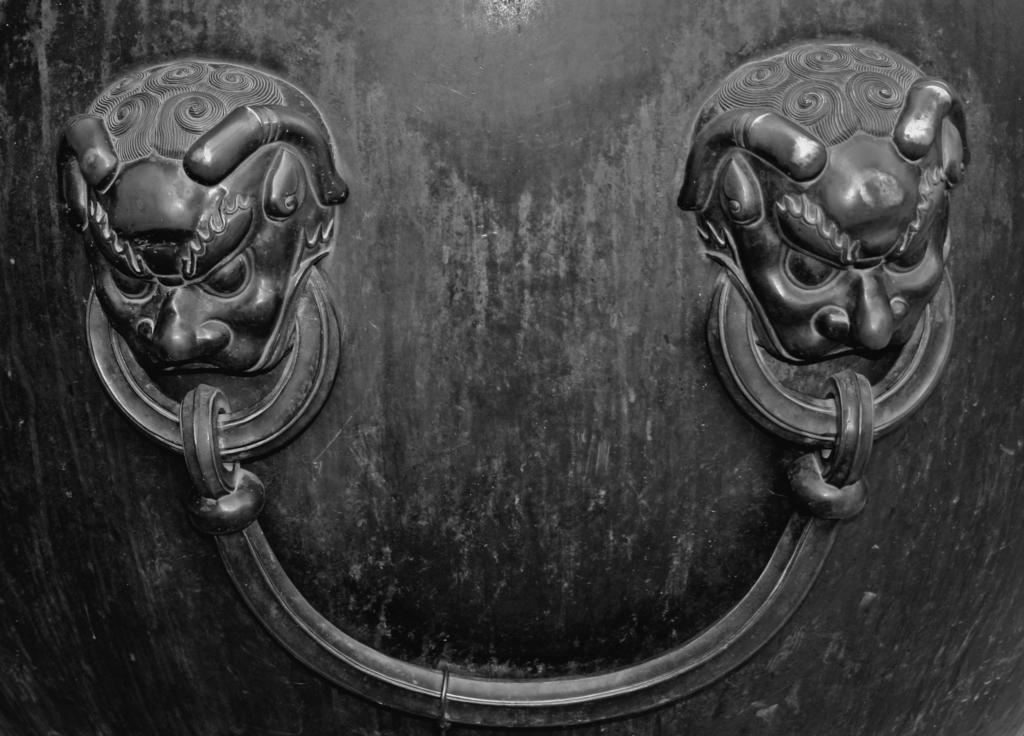What is a prominent feature in the image? There is a door in the image. What is unique about the door? The door has sculptures on it. Where is the machine located in the image? There is no machine present in the image. What type of alley can be seen in the image? There is no alley present in the image. 